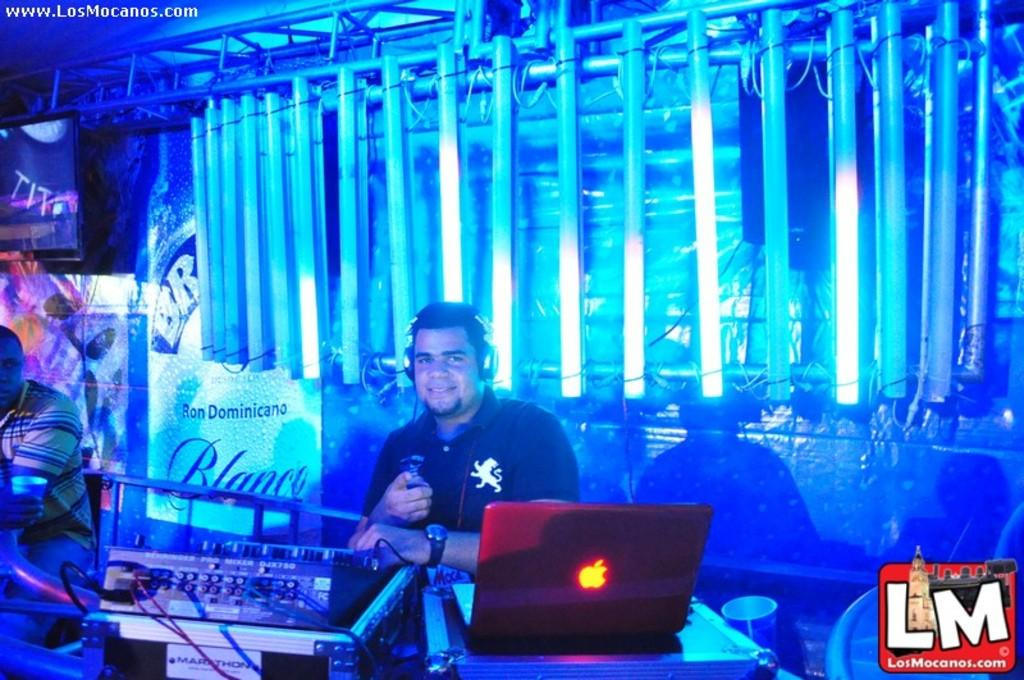<image>
Share a concise interpretation of the image provided. A DJ smile next to a sign that has the word "blanco" on it. 